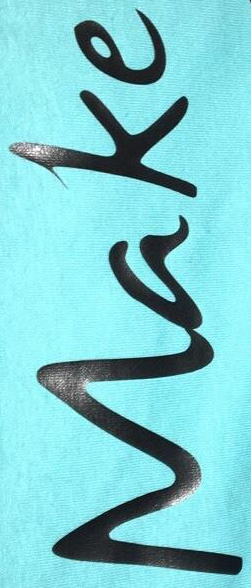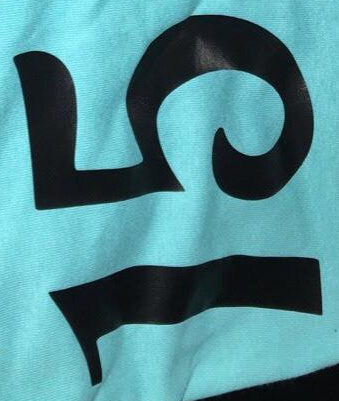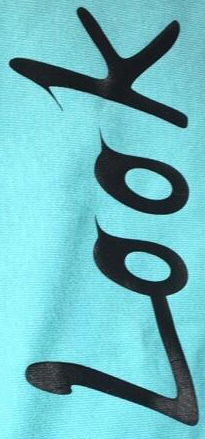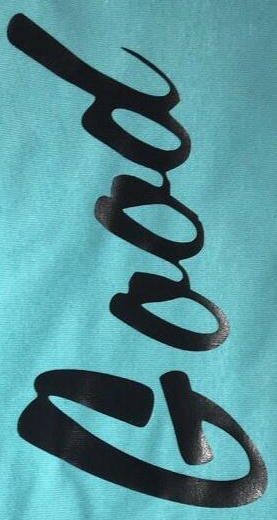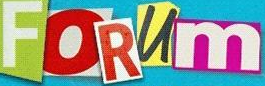What text is displayed in these images sequentially, separated by a semicolon? Make; 15; Look; Good; FORUm 